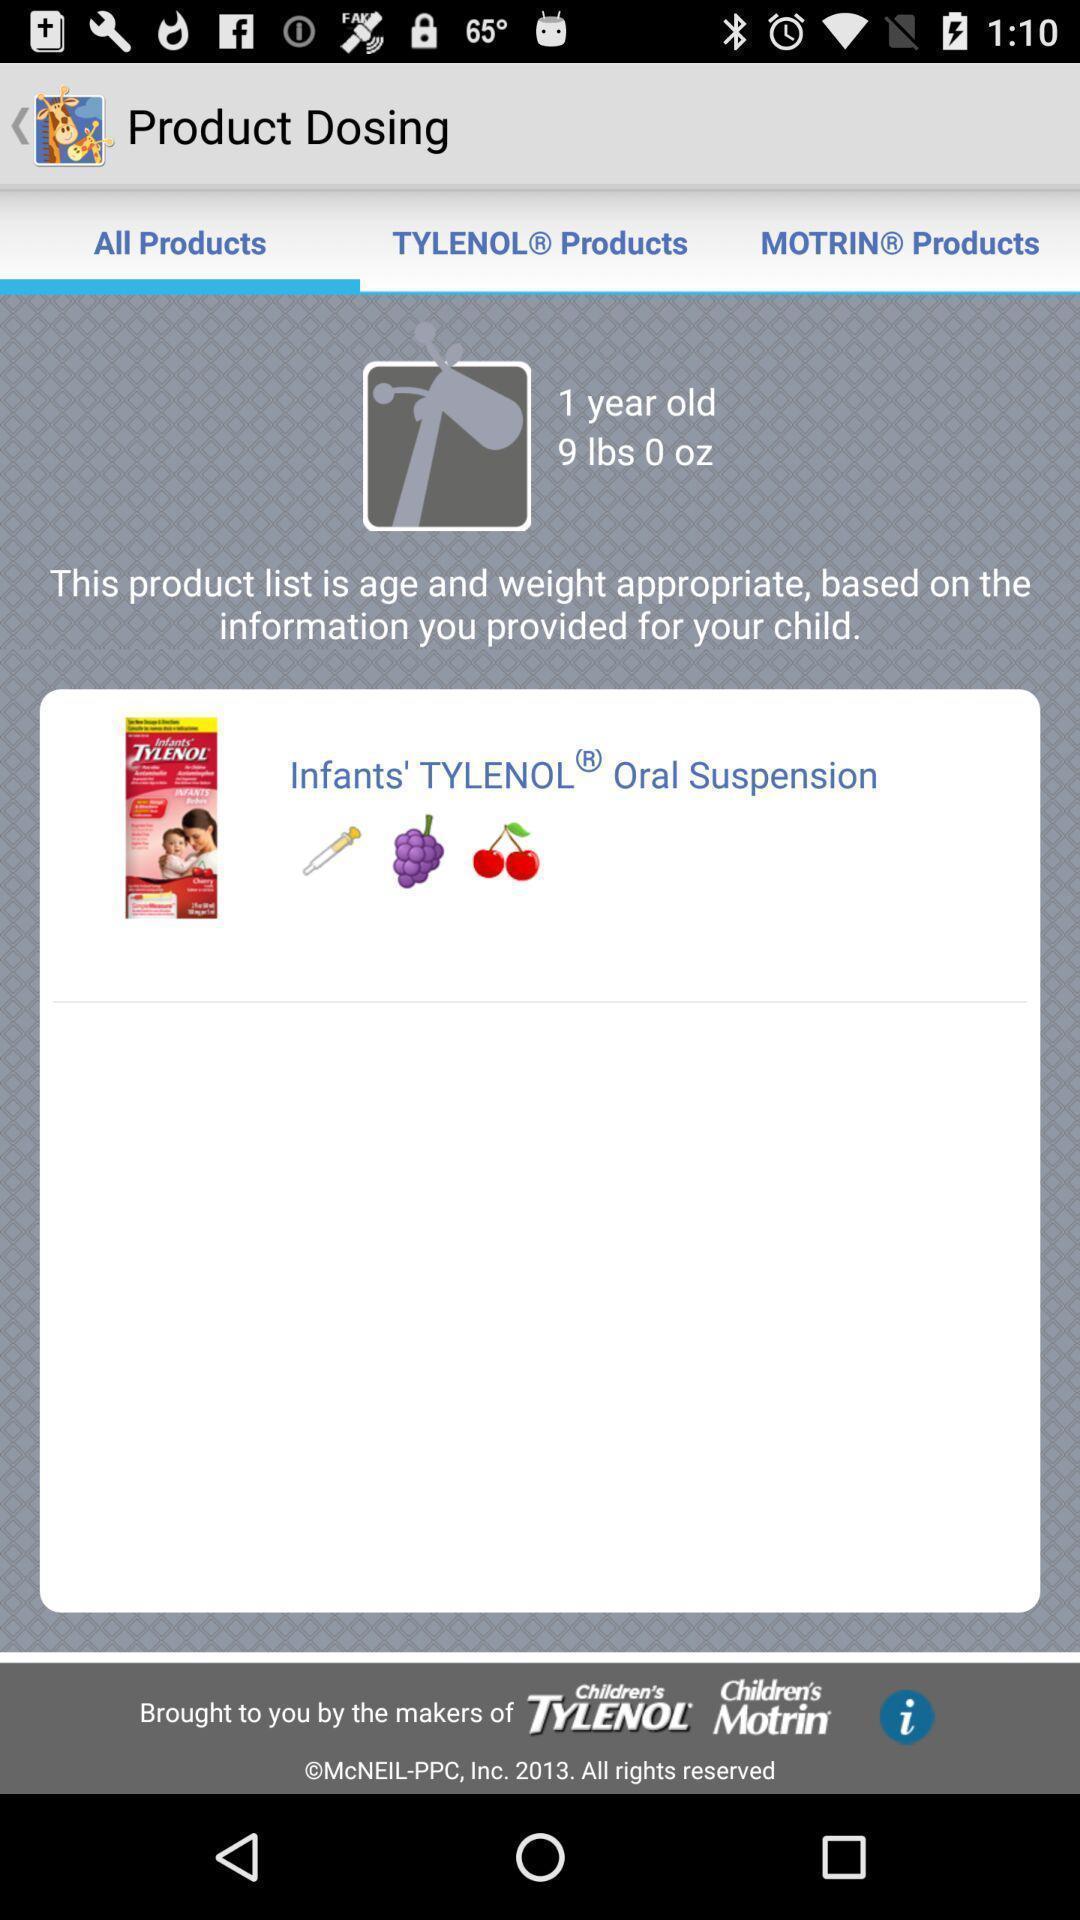What details can you identify in this image? Screen displaying the product page. 